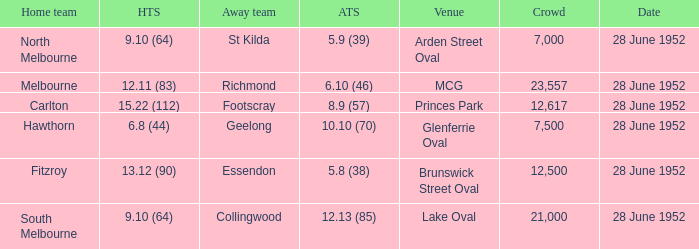What is the home team's score when the venue is princes park? 15.22 (112). Give me the full table as a dictionary. {'header': ['Home team', 'HTS', 'Away team', 'ATS', 'Venue', 'Crowd', 'Date'], 'rows': [['North Melbourne', '9.10 (64)', 'St Kilda', '5.9 (39)', 'Arden Street Oval', '7,000', '28 June 1952'], ['Melbourne', '12.11 (83)', 'Richmond', '6.10 (46)', 'MCG', '23,557', '28 June 1952'], ['Carlton', '15.22 (112)', 'Footscray', '8.9 (57)', 'Princes Park', '12,617', '28 June 1952'], ['Hawthorn', '6.8 (44)', 'Geelong', '10.10 (70)', 'Glenferrie Oval', '7,500', '28 June 1952'], ['Fitzroy', '13.12 (90)', 'Essendon', '5.8 (38)', 'Brunswick Street Oval', '12,500', '28 June 1952'], ['South Melbourne', '9.10 (64)', 'Collingwood', '12.13 (85)', 'Lake Oval', '21,000', '28 June 1952']]} 